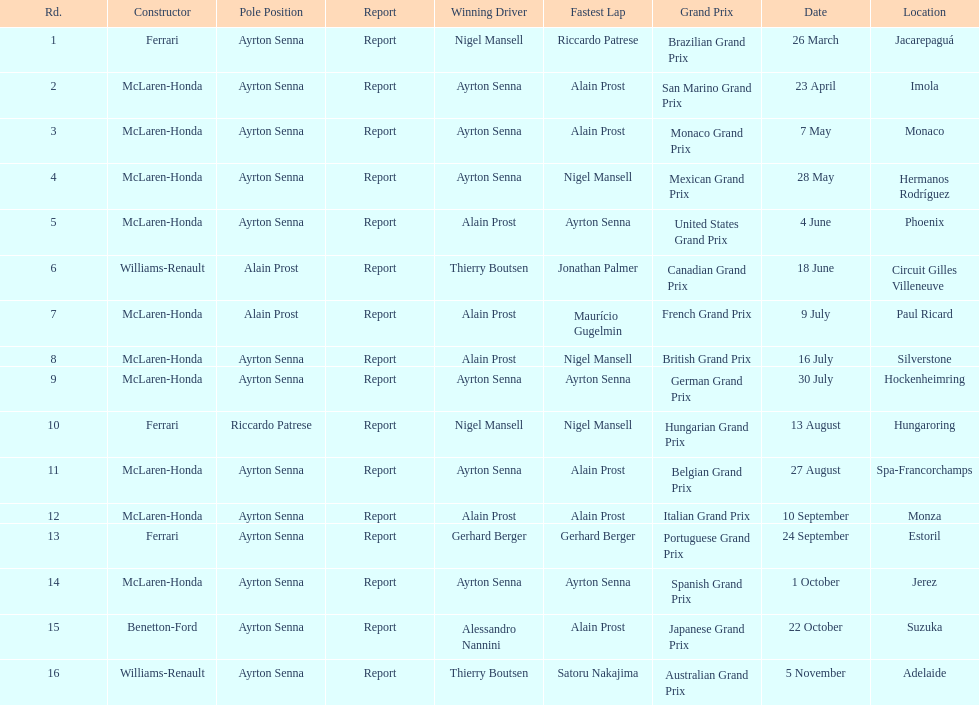Prost won the drivers title, who was his teammate? Ayrton Senna. 